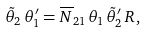Convert formula to latex. <formula><loc_0><loc_0><loc_500><loc_500>\tilde { \theta } _ { 2 } \, \theta _ { 1 } ^ { \prime } = \overline { N } _ { 2 1 } \, \theta _ { 1 } \, \tilde { \theta } _ { 2 } ^ { \prime } \, R \, ,</formula> 